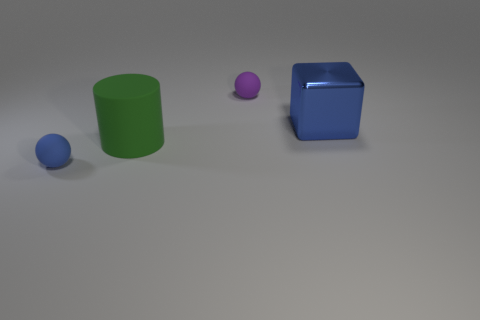Can you describe the lighting in the scene? The lighting appears to be coming from above, casting soft shadows directly beneath the objects. 